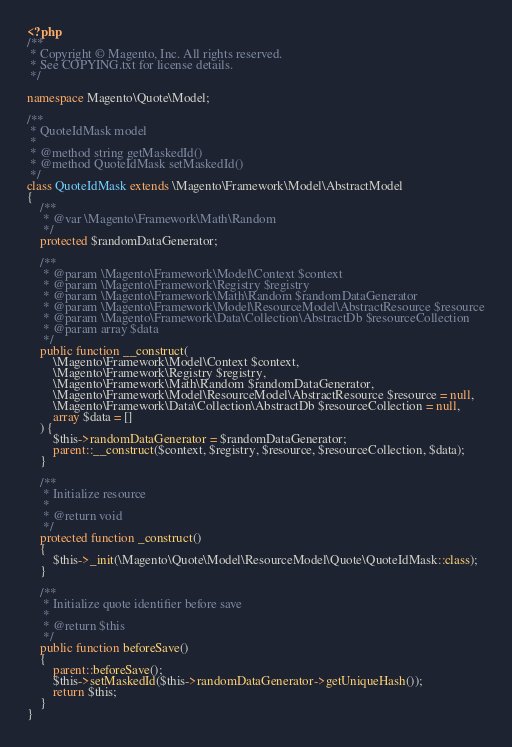Convert code to text. <code><loc_0><loc_0><loc_500><loc_500><_PHP_><?php
/**
 * Copyright © Magento, Inc. All rights reserved.
 * See COPYING.txt for license details.
 */

namespace Magento\Quote\Model;

/**
 * QuoteIdMask model
 *
 * @method string getMaskedId()
 * @method QuoteIdMask setMaskedId()
 */
class QuoteIdMask extends \Magento\Framework\Model\AbstractModel
{
    /**
     * @var \Magento\Framework\Math\Random
     */
    protected $randomDataGenerator;

    /**
     * @param \Magento\Framework\Model\Context $context
     * @param \Magento\Framework\Registry $registry
     * @param \Magento\Framework\Math\Random $randomDataGenerator
     * @param \Magento\Framework\Model\ResourceModel\AbstractResource $resource
     * @param \Magento\Framework\Data\Collection\AbstractDb $resourceCollection
     * @param array $data
     */
    public function __construct(
        \Magento\Framework\Model\Context $context,
        \Magento\Framework\Registry $registry,
        \Magento\Framework\Math\Random $randomDataGenerator,
        \Magento\Framework\Model\ResourceModel\AbstractResource $resource = null,
        \Magento\Framework\Data\Collection\AbstractDb $resourceCollection = null,
        array $data = []
    ) {
        $this->randomDataGenerator = $randomDataGenerator;
        parent::__construct($context, $registry, $resource, $resourceCollection, $data);
    }

    /**
     * Initialize resource
     *
     * @return void
     */
    protected function _construct()
    {
        $this->_init(\Magento\Quote\Model\ResourceModel\Quote\QuoteIdMask::class);
    }

    /**
     * Initialize quote identifier before save
     *
     * @return $this
     */
    public function beforeSave()
    {
        parent::beforeSave();
        $this->setMaskedId($this->randomDataGenerator->getUniqueHash());
        return $this;
    }
}
</code> 